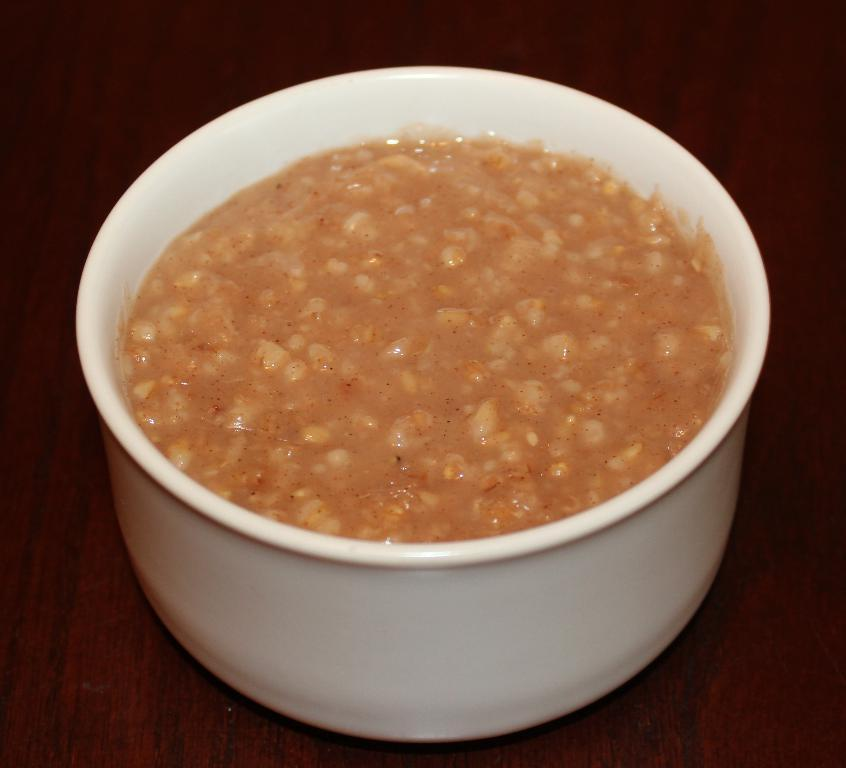What is in the bowl that is visible in the image? There is a bowl of food item in the image. Where is the bowl located in the image? The bowl is in the center of the image. On what surface is the bowl placed? The bowl is on a table. What type of skin can be seen on the table in the image? There is no skin visible in the image, as the table is an inanimate object. 